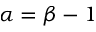<formula> <loc_0><loc_0><loc_500><loc_500>\alpha = \beta - 1</formula> 